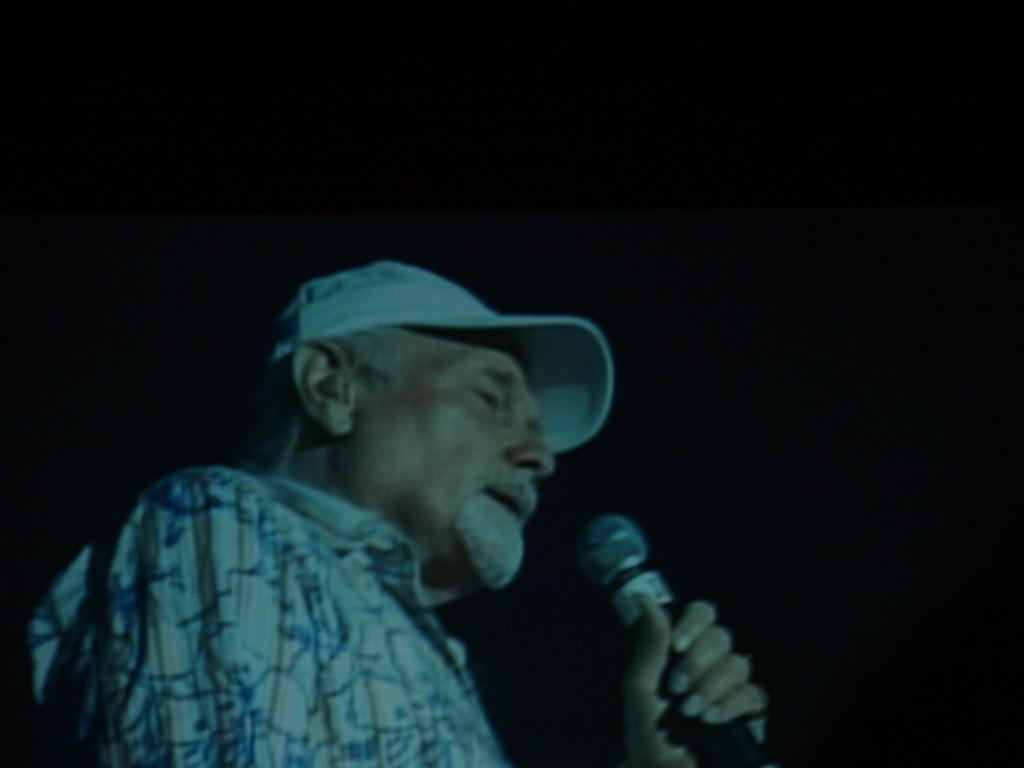Who is the main subject in the image? There is a man in the image. What is the man holding in the image? The man is holding a microphone. What type of headwear is the man wearing? The man is wearing a cap. What can be observed about the background of the image? The background of the image is dark. What type of toy can be seen hanging from the man's cap in the image? There is no toy hanging from the man's cap in the image. What is the man eating for dinner in the image? There is no dinner or food visible in the image. 